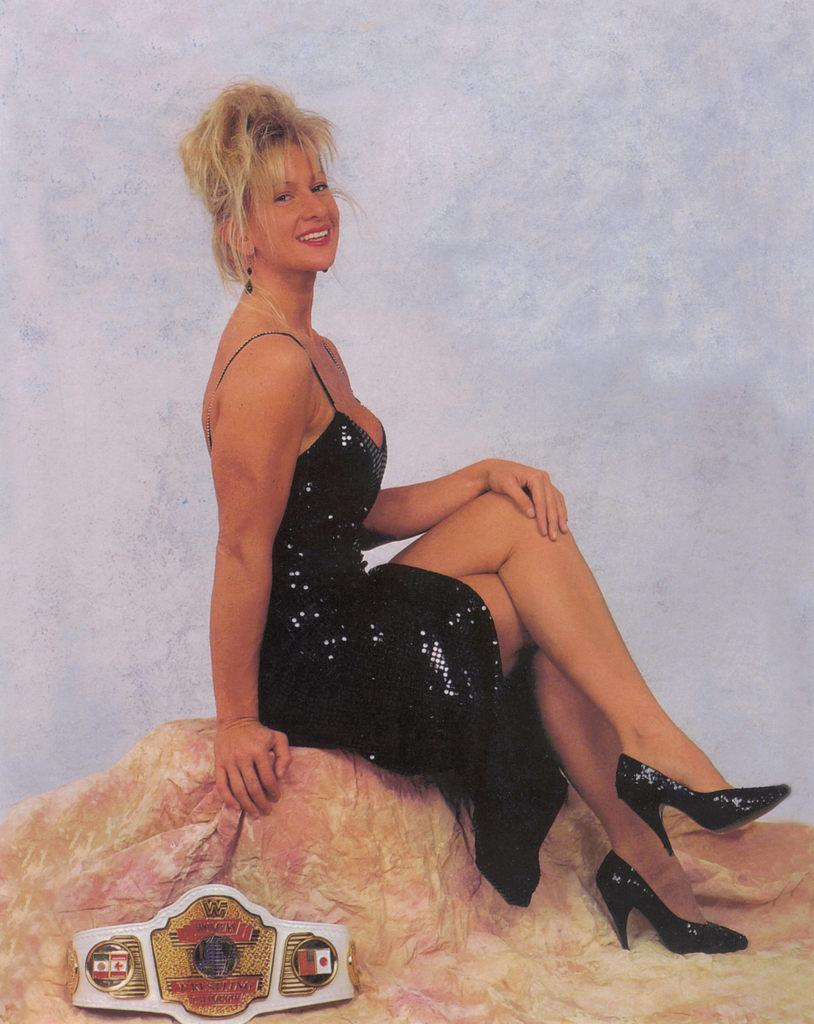Who is present in the image? There is a woman in the image. What is the woman doing in the image? The woman is sitting on a rock. What is the woman wearing in the image? The woman is wearing a black dress. What can be seen behind the woman in the image? There is a wall behind the woman. What type of government is depicted in the image? There is no depiction of a government in the image; it features a woman sitting on a rock wearing a black dress with a wall behind her. 